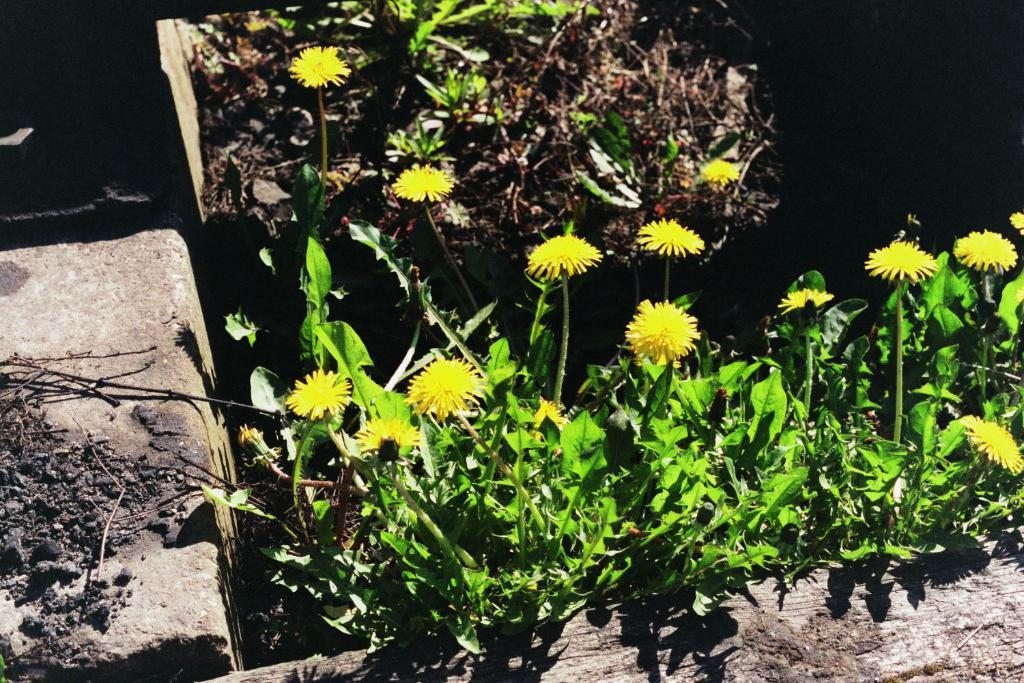What type of flowers can be seen on the plants in the image? There are yellow flowers on plants in the image. What is located on the right side of the image? There is a slab on the right side of the image. What is placed on the slab? There are items on the slab. What can be seen in the background of the image? There are plants and other unspecified things in the background of the image. Can you describe the pet that is holding the hands in the image? There is no pet or hands present in the image. 